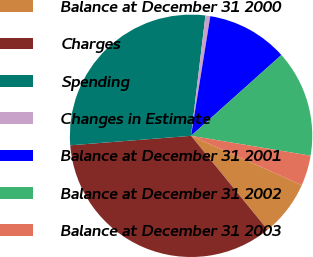<chart> <loc_0><loc_0><loc_500><loc_500><pie_chart><fcel>Balance at December 31 2000<fcel>Charges<fcel>Spending<fcel>Changes in Estimate<fcel>Balance at December 31 2001<fcel>Balance at December 31 2002<fcel>Balance at December 31 2003<nl><fcel>7.45%<fcel>34.63%<fcel>28.14%<fcel>0.65%<fcel>10.84%<fcel>14.24%<fcel>4.05%<nl></chart> 